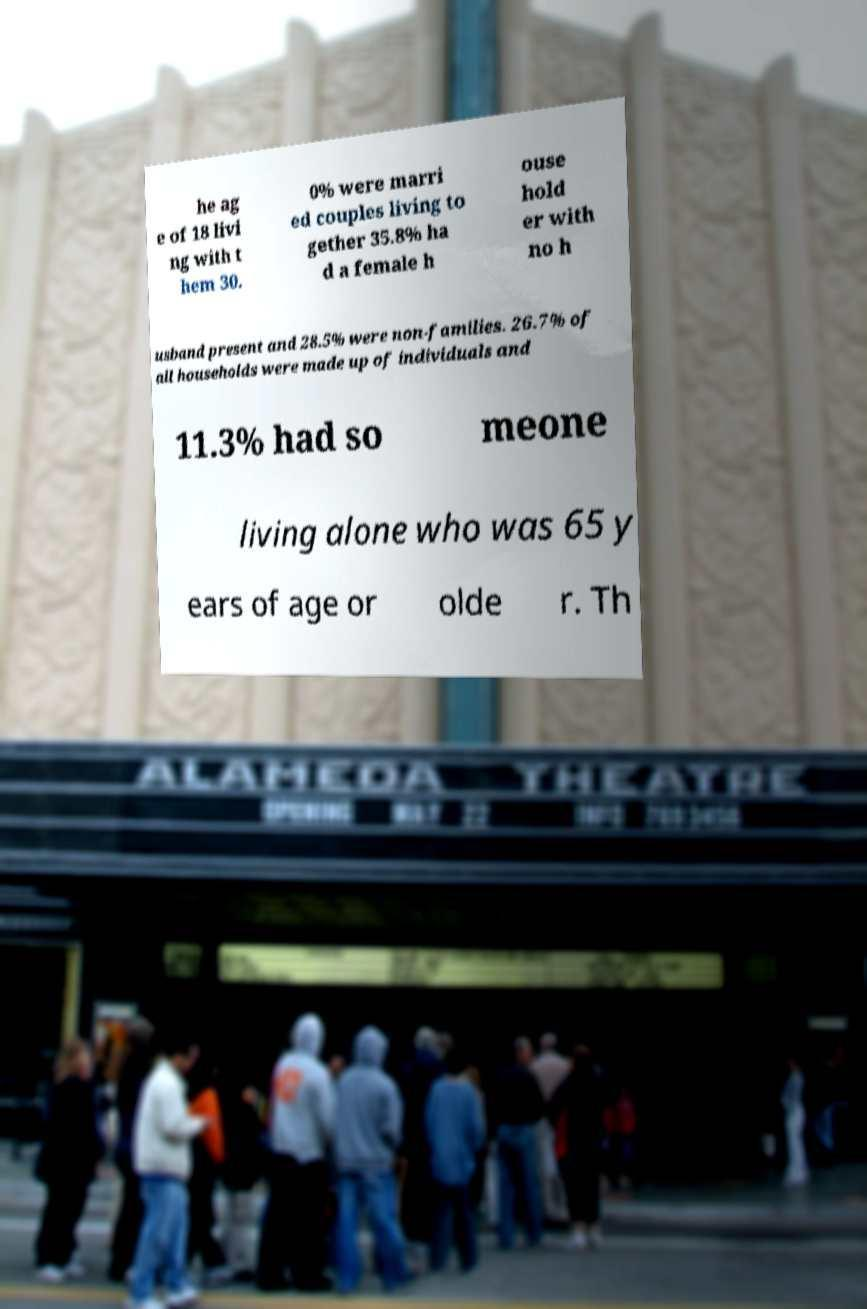Can you accurately transcribe the text from the provided image for me? he ag e of 18 livi ng with t hem 30. 0% were marri ed couples living to gether 35.8% ha d a female h ouse hold er with no h usband present and 28.5% were non-families. 26.7% of all households were made up of individuals and 11.3% had so meone living alone who was 65 y ears of age or olde r. Th 